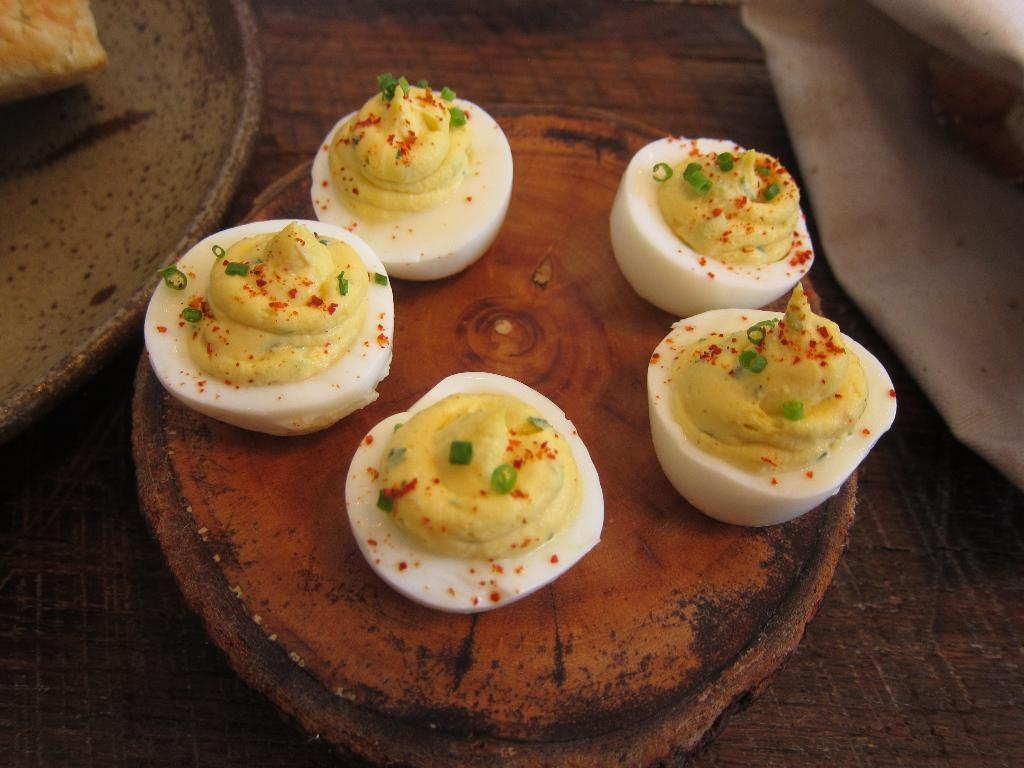What objects are present in the image? There are eggs in the image. How are the eggs arranged or placed in the image? The eggs are on a wooden tray. What type of weather can be seen in the image? There is no weather depicted in the image, as it only features eggs on a wooden tray. Are there any corn plants visible in the image? There are no corn plants present in the image. 